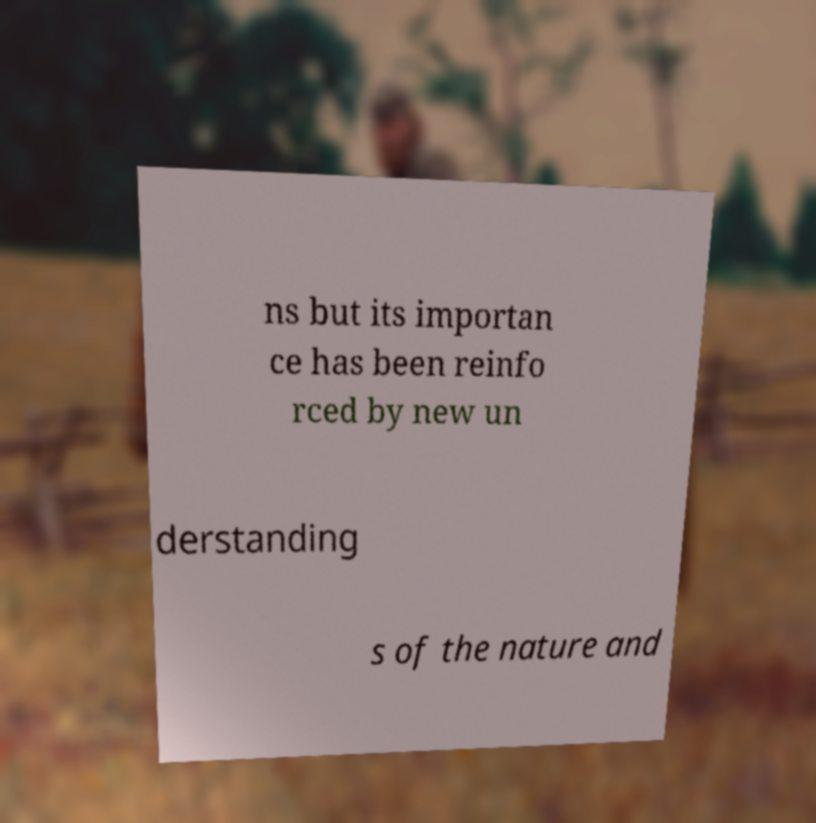For documentation purposes, I need the text within this image transcribed. Could you provide that? ns but its importan ce has been reinfo rced by new un derstanding s of the nature and 